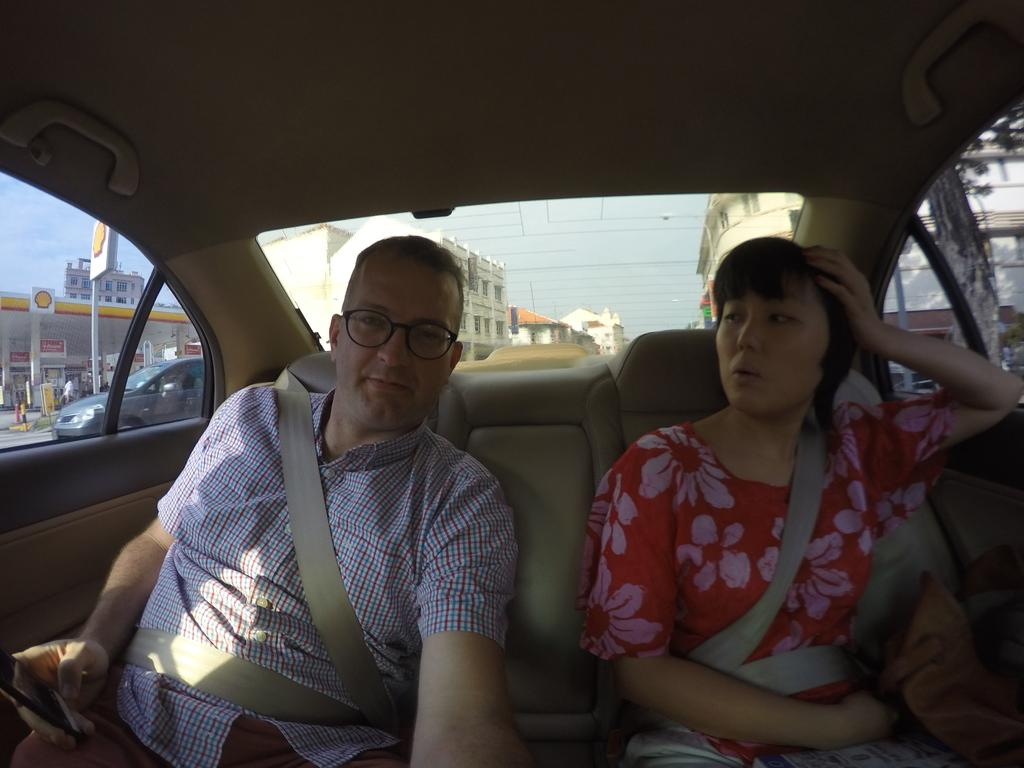How many people are in the image? There are two people in the image, a woman and a man. What are they doing in the image? They are sitting inside a car. What safety measure are they taking while sitting in the car? They are wearing seat belts. What can be seen through the car's glass? A petrol bunk, huge buildings, the sky, and another car can be seen through the car's glass. What type of coach can be seen in the image? There is no coach present in the image; it features a woman and a man sitting inside a car. Is there a writer visible in the image? There is no writer present in the image; it features a woman and a man sitting inside a car. 